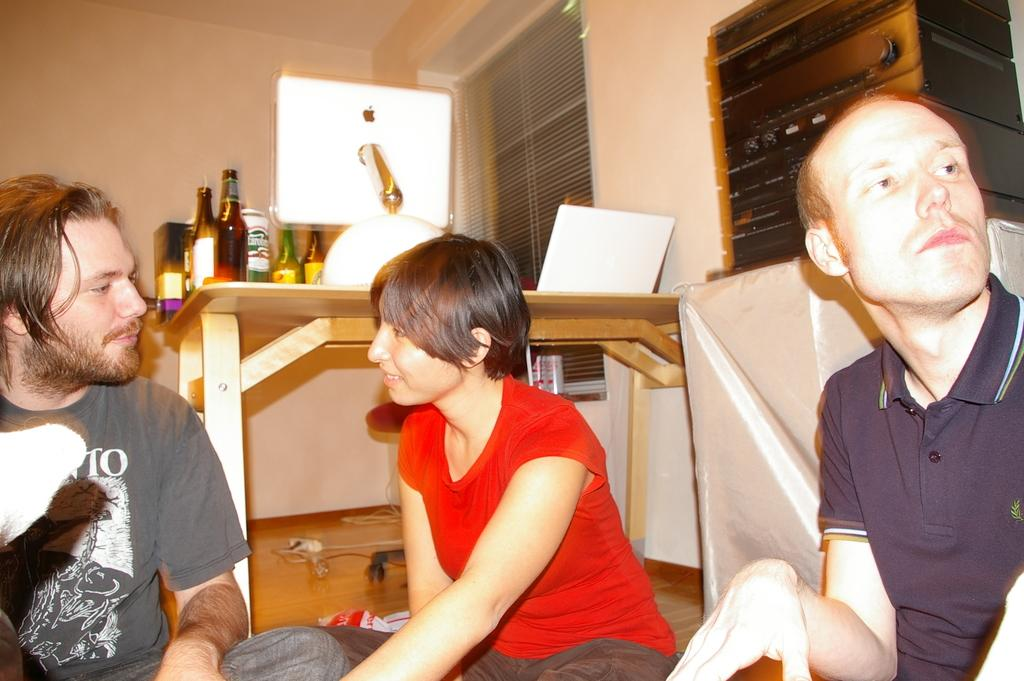How many people are in the image? There are two men and a woman in the image, making a total of three people. What are the people in the image doing? They are sitting on the ground. What objects can be seen on the table in the image? There is a bottle, a box, and a laptop on the table. What type of cover is present in the image? There is a cover in the image, but its specific type is not mentioned. Can you describe any other objects in the image? Yes, there are other objects in the image, but their details are not provided. What time of day is it in the image, and are the people in the image brothers? The time of day is not mentioned in the image, and there is no information provided about the relationship between the people. How many trucks are visible in the image? There are no trucks present in the image. 